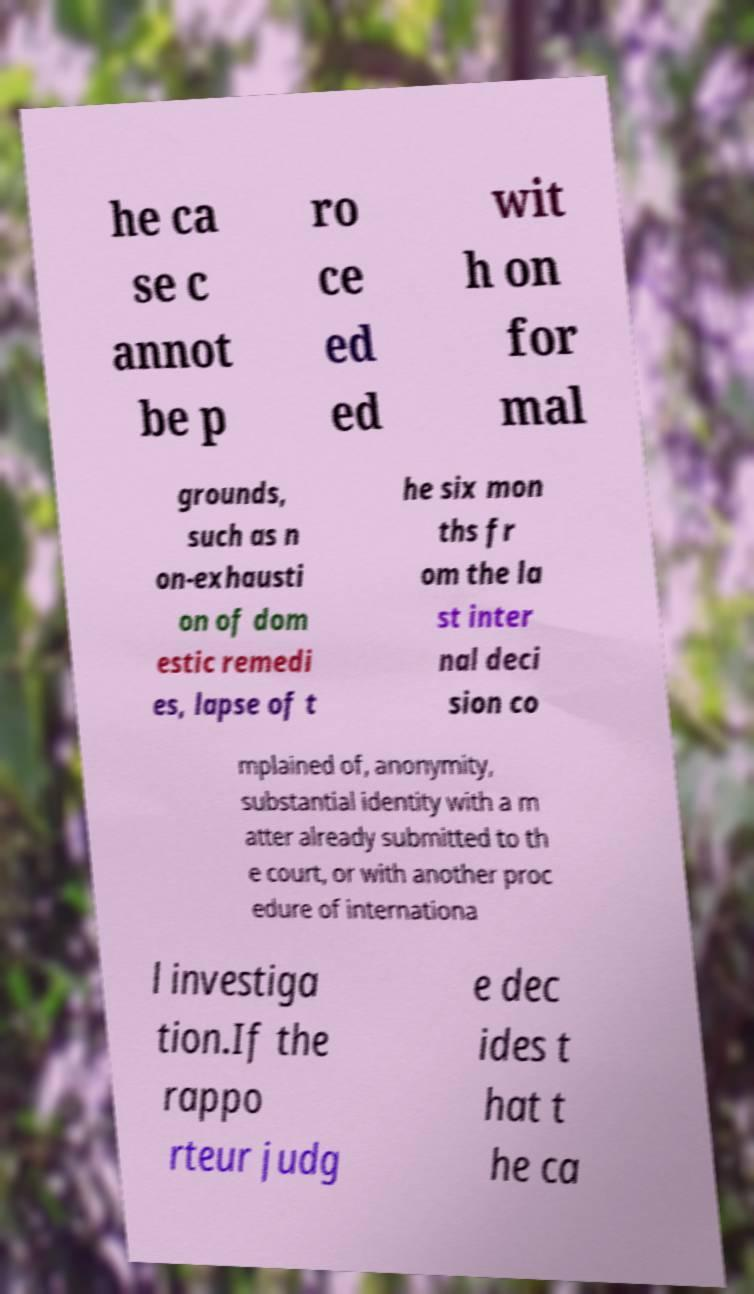Please read and relay the text visible in this image. What does it say? he ca se c annot be p ro ce ed ed wit h on for mal grounds, such as n on-exhausti on of dom estic remedi es, lapse of t he six mon ths fr om the la st inter nal deci sion co mplained of, anonymity, substantial identity with a m atter already submitted to th e court, or with another proc edure of internationa l investiga tion.If the rappo rteur judg e dec ides t hat t he ca 